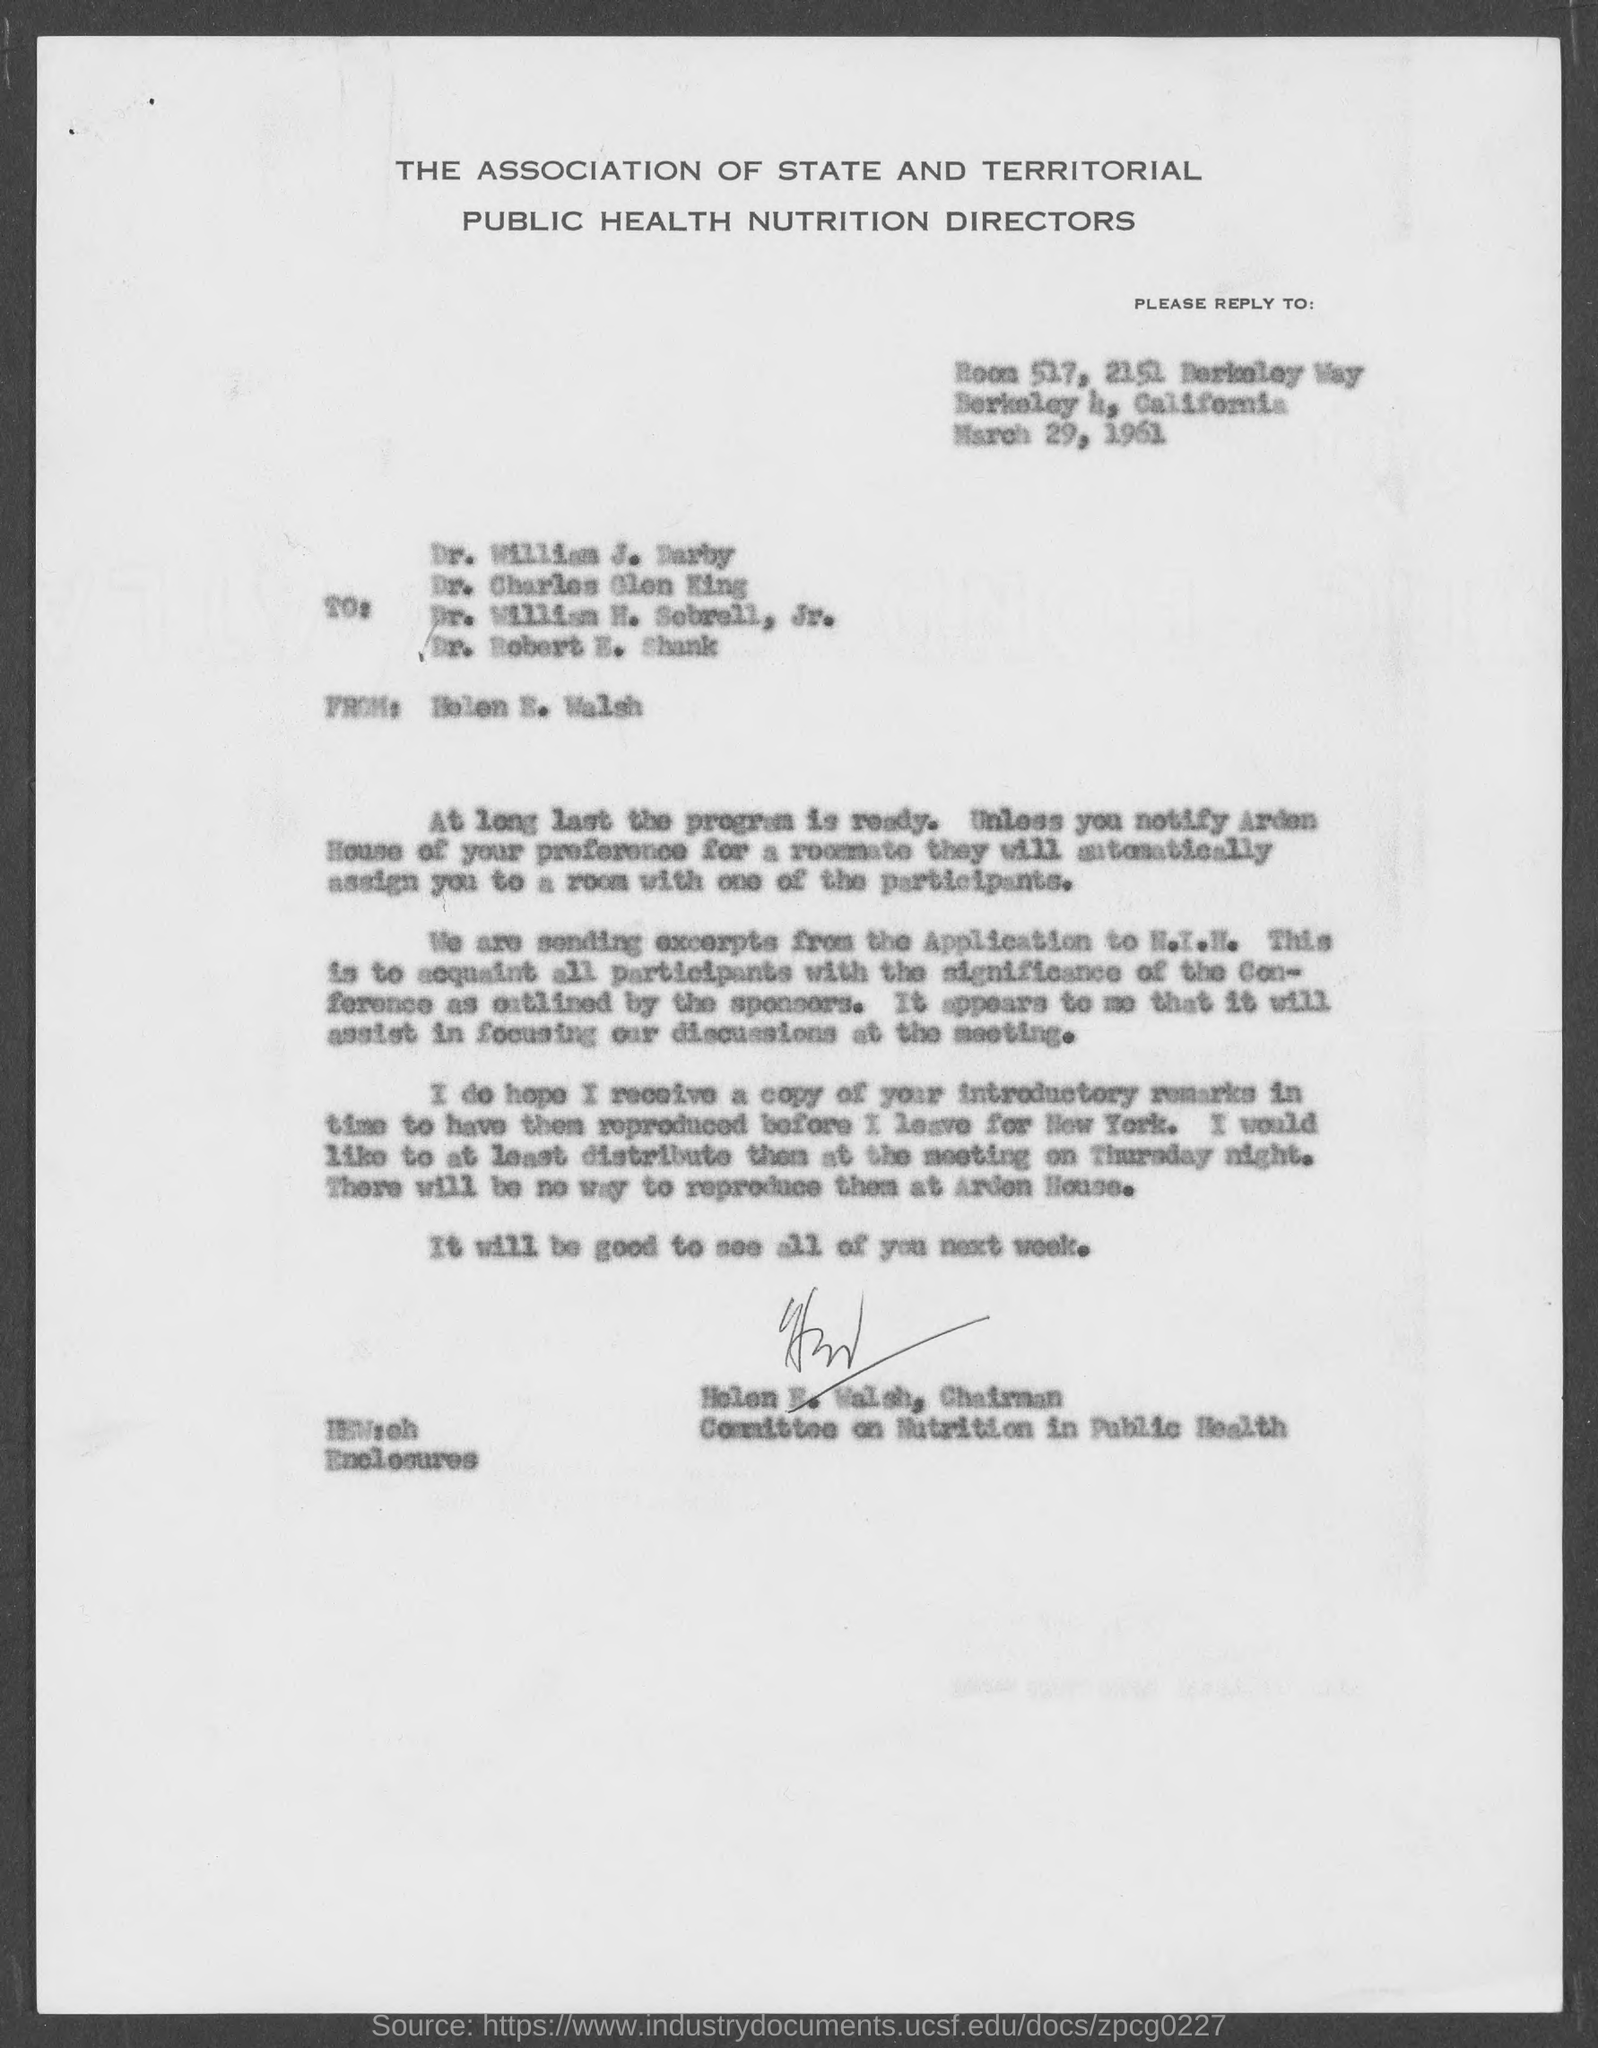Which association is this ?
Give a very brief answer. THE ASSOCIATION OF STATE AND TERRITORIAL PUBLIC HEALTH NUTRITION DIRECTORS. When the letter is sent ?
Give a very brief answer. March 29, 1961. Who sent the letter ?
Provide a short and direct response. Helen E. Walsh. Who is the first recipient?
Offer a terse response. Dr. William J. Darby. "Helen E" is the chairman of which commitee?
Offer a very short reply. Committee on Nutrition in Public Health. 